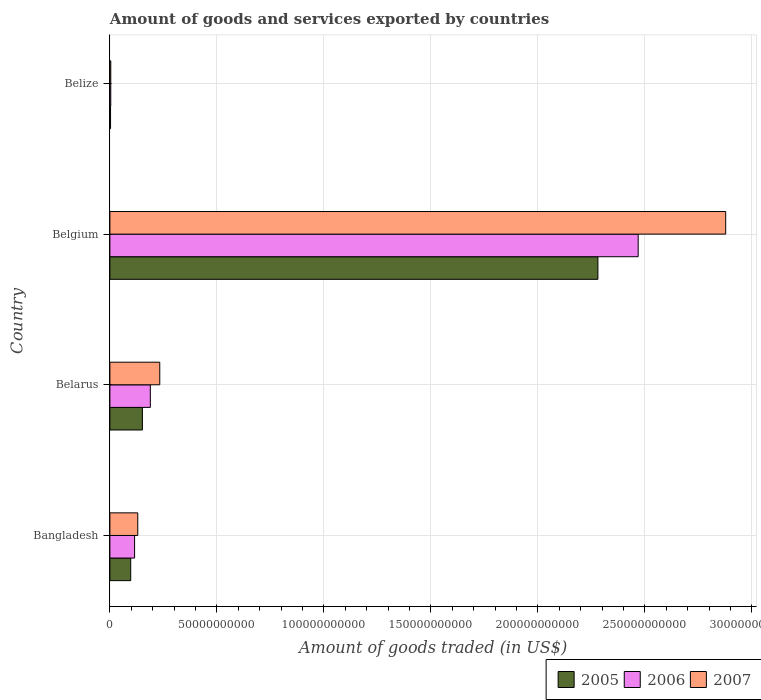How many different coloured bars are there?
Ensure brevity in your answer.  3. How many groups of bars are there?
Offer a terse response. 4. Are the number of bars per tick equal to the number of legend labels?
Your response must be concise. Yes. Are the number of bars on each tick of the Y-axis equal?
Offer a terse response. Yes. In how many cases, is the number of bars for a given country not equal to the number of legend labels?
Ensure brevity in your answer.  0. What is the total amount of goods and services exported in 2005 in Bangladesh?
Give a very brief answer. 9.73e+09. Across all countries, what is the maximum total amount of goods and services exported in 2006?
Provide a short and direct response. 2.47e+11. Across all countries, what is the minimum total amount of goods and services exported in 2007?
Keep it short and to the point. 4.16e+08. In which country was the total amount of goods and services exported in 2007 minimum?
Your answer should be compact. Belize. What is the total total amount of goods and services exported in 2005 in the graph?
Provide a short and direct response. 2.53e+11. What is the difference between the total amount of goods and services exported in 2007 in Bangladesh and that in Belize?
Your answer should be compact. 1.26e+1. What is the difference between the total amount of goods and services exported in 2007 in Bangladesh and the total amount of goods and services exported in 2006 in Belarus?
Offer a very short reply. -5.87e+09. What is the average total amount of goods and services exported in 2006 per country?
Provide a succinct answer. 6.94e+1. What is the difference between the total amount of goods and services exported in 2006 and total amount of goods and services exported in 2007 in Belize?
Ensure brevity in your answer.  -7.34e+06. What is the ratio of the total amount of goods and services exported in 2007 in Belarus to that in Belize?
Make the answer very short. 56. Is the difference between the total amount of goods and services exported in 2006 in Bangladesh and Belize greater than the difference between the total amount of goods and services exported in 2007 in Bangladesh and Belize?
Give a very brief answer. No. What is the difference between the highest and the second highest total amount of goods and services exported in 2007?
Your answer should be very brief. 2.64e+11. What is the difference between the highest and the lowest total amount of goods and services exported in 2007?
Make the answer very short. 2.87e+11. In how many countries, is the total amount of goods and services exported in 2005 greater than the average total amount of goods and services exported in 2005 taken over all countries?
Offer a terse response. 1. Is the sum of the total amount of goods and services exported in 2006 in Belarus and Belize greater than the maximum total amount of goods and services exported in 2007 across all countries?
Keep it short and to the point. No. Is it the case that in every country, the sum of the total amount of goods and services exported in 2006 and total amount of goods and services exported in 2007 is greater than the total amount of goods and services exported in 2005?
Ensure brevity in your answer.  Yes. How many bars are there?
Your answer should be very brief. 12. How many countries are there in the graph?
Your answer should be compact. 4. Are the values on the major ticks of X-axis written in scientific E-notation?
Provide a short and direct response. No. Does the graph contain any zero values?
Your answer should be compact. No. What is the title of the graph?
Provide a short and direct response. Amount of goods and services exported by countries. Does "1998" appear as one of the legend labels in the graph?
Give a very brief answer. No. What is the label or title of the X-axis?
Your answer should be compact. Amount of goods traded (in US$). What is the label or title of the Y-axis?
Ensure brevity in your answer.  Country. What is the Amount of goods traded (in US$) of 2005 in Bangladesh?
Make the answer very short. 9.73e+09. What is the Amount of goods traded (in US$) of 2006 in Bangladesh?
Offer a terse response. 1.15e+1. What is the Amount of goods traded (in US$) in 2007 in Bangladesh?
Give a very brief answer. 1.30e+1. What is the Amount of goods traded (in US$) in 2005 in Belarus?
Provide a short and direct response. 1.52e+1. What is the Amount of goods traded (in US$) of 2006 in Belarus?
Your answer should be very brief. 1.89e+1. What is the Amount of goods traded (in US$) in 2007 in Belarus?
Your response must be concise. 2.33e+1. What is the Amount of goods traded (in US$) of 2005 in Belgium?
Keep it short and to the point. 2.28e+11. What is the Amount of goods traded (in US$) of 2006 in Belgium?
Offer a very short reply. 2.47e+11. What is the Amount of goods traded (in US$) in 2007 in Belgium?
Make the answer very short. 2.88e+11. What is the Amount of goods traded (in US$) of 2005 in Belize?
Your answer should be very brief. 3.08e+08. What is the Amount of goods traded (in US$) of 2006 in Belize?
Your answer should be very brief. 4.09e+08. What is the Amount of goods traded (in US$) of 2007 in Belize?
Offer a very short reply. 4.16e+08. Across all countries, what is the maximum Amount of goods traded (in US$) in 2005?
Offer a very short reply. 2.28e+11. Across all countries, what is the maximum Amount of goods traded (in US$) of 2006?
Offer a very short reply. 2.47e+11. Across all countries, what is the maximum Amount of goods traded (in US$) of 2007?
Offer a terse response. 2.88e+11. Across all countries, what is the minimum Amount of goods traded (in US$) of 2005?
Your answer should be very brief. 3.08e+08. Across all countries, what is the minimum Amount of goods traded (in US$) in 2006?
Keep it short and to the point. 4.09e+08. Across all countries, what is the minimum Amount of goods traded (in US$) of 2007?
Provide a succinct answer. 4.16e+08. What is the total Amount of goods traded (in US$) in 2005 in the graph?
Offer a very short reply. 2.53e+11. What is the total Amount of goods traded (in US$) of 2006 in the graph?
Provide a succinct answer. 2.78e+11. What is the total Amount of goods traded (in US$) of 2007 in the graph?
Your response must be concise. 3.25e+11. What is the difference between the Amount of goods traded (in US$) in 2005 in Bangladesh and that in Belarus?
Give a very brief answer. -5.46e+09. What is the difference between the Amount of goods traded (in US$) in 2006 in Bangladesh and that in Belarus?
Make the answer very short. -7.35e+09. What is the difference between the Amount of goods traded (in US$) of 2007 in Bangladesh and that in Belarus?
Offer a very short reply. -1.03e+1. What is the difference between the Amount of goods traded (in US$) in 2005 in Bangladesh and that in Belgium?
Offer a terse response. -2.18e+11. What is the difference between the Amount of goods traded (in US$) of 2006 in Bangladesh and that in Belgium?
Offer a terse response. -2.35e+11. What is the difference between the Amount of goods traded (in US$) of 2007 in Bangladesh and that in Belgium?
Keep it short and to the point. -2.75e+11. What is the difference between the Amount of goods traded (in US$) of 2005 in Bangladesh and that in Belize?
Your answer should be very brief. 9.42e+09. What is the difference between the Amount of goods traded (in US$) in 2006 in Bangladesh and that in Belize?
Make the answer very short. 1.11e+1. What is the difference between the Amount of goods traded (in US$) in 2007 in Bangladesh and that in Belize?
Your answer should be very brief. 1.26e+1. What is the difference between the Amount of goods traded (in US$) of 2005 in Belarus and that in Belgium?
Your answer should be very brief. -2.13e+11. What is the difference between the Amount of goods traded (in US$) of 2006 in Belarus and that in Belgium?
Ensure brevity in your answer.  -2.28e+11. What is the difference between the Amount of goods traded (in US$) in 2007 in Belarus and that in Belgium?
Offer a terse response. -2.64e+11. What is the difference between the Amount of goods traded (in US$) of 2005 in Belarus and that in Belize?
Offer a very short reply. 1.49e+1. What is the difference between the Amount of goods traded (in US$) in 2006 in Belarus and that in Belize?
Your response must be concise. 1.85e+1. What is the difference between the Amount of goods traded (in US$) of 2007 in Belarus and that in Belize?
Provide a short and direct response. 2.29e+1. What is the difference between the Amount of goods traded (in US$) of 2005 in Belgium and that in Belize?
Give a very brief answer. 2.28e+11. What is the difference between the Amount of goods traded (in US$) in 2006 in Belgium and that in Belize?
Offer a very short reply. 2.46e+11. What is the difference between the Amount of goods traded (in US$) of 2007 in Belgium and that in Belize?
Give a very brief answer. 2.87e+11. What is the difference between the Amount of goods traded (in US$) in 2005 in Bangladesh and the Amount of goods traded (in US$) in 2006 in Belarus?
Provide a short and direct response. -9.16e+09. What is the difference between the Amount of goods traded (in US$) in 2005 in Bangladesh and the Amount of goods traded (in US$) in 2007 in Belarus?
Your answer should be compact. -1.36e+1. What is the difference between the Amount of goods traded (in US$) of 2006 in Bangladesh and the Amount of goods traded (in US$) of 2007 in Belarus?
Ensure brevity in your answer.  -1.18e+1. What is the difference between the Amount of goods traded (in US$) in 2005 in Bangladesh and the Amount of goods traded (in US$) in 2006 in Belgium?
Offer a very short reply. -2.37e+11. What is the difference between the Amount of goods traded (in US$) in 2005 in Bangladesh and the Amount of goods traded (in US$) in 2007 in Belgium?
Your answer should be very brief. -2.78e+11. What is the difference between the Amount of goods traded (in US$) in 2006 in Bangladesh and the Amount of goods traded (in US$) in 2007 in Belgium?
Keep it short and to the point. -2.76e+11. What is the difference between the Amount of goods traded (in US$) in 2005 in Bangladesh and the Amount of goods traded (in US$) in 2006 in Belize?
Offer a terse response. 9.32e+09. What is the difference between the Amount of goods traded (in US$) in 2005 in Bangladesh and the Amount of goods traded (in US$) in 2007 in Belize?
Keep it short and to the point. 9.32e+09. What is the difference between the Amount of goods traded (in US$) of 2006 in Bangladesh and the Amount of goods traded (in US$) of 2007 in Belize?
Keep it short and to the point. 1.11e+1. What is the difference between the Amount of goods traded (in US$) in 2005 in Belarus and the Amount of goods traded (in US$) in 2006 in Belgium?
Provide a short and direct response. -2.32e+11. What is the difference between the Amount of goods traded (in US$) of 2005 in Belarus and the Amount of goods traded (in US$) of 2007 in Belgium?
Your response must be concise. -2.73e+11. What is the difference between the Amount of goods traded (in US$) in 2006 in Belarus and the Amount of goods traded (in US$) in 2007 in Belgium?
Offer a terse response. -2.69e+11. What is the difference between the Amount of goods traded (in US$) in 2005 in Belarus and the Amount of goods traded (in US$) in 2006 in Belize?
Your answer should be compact. 1.48e+1. What is the difference between the Amount of goods traded (in US$) of 2005 in Belarus and the Amount of goods traded (in US$) of 2007 in Belize?
Give a very brief answer. 1.48e+1. What is the difference between the Amount of goods traded (in US$) in 2006 in Belarus and the Amount of goods traded (in US$) in 2007 in Belize?
Your response must be concise. 1.85e+1. What is the difference between the Amount of goods traded (in US$) in 2005 in Belgium and the Amount of goods traded (in US$) in 2006 in Belize?
Keep it short and to the point. 2.28e+11. What is the difference between the Amount of goods traded (in US$) in 2005 in Belgium and the Amount of goods traded (in US$) in 2007 in Belize?
Provide a short and direct response. 2.28e+11. What is the difference between the Amount of goods traded (in US$) of 2006 in Belgium and the Amount of goods traded (in US$) of 2007 in Belize?
Keep it short and to the point. 2.46e+11. What is the average Amount of goods traded (in US$) in 2005 per country?
Offer a terse response. 6.33e+1. What is the average Amount of goods traded (in US$) of 2006 per country?
Offer a very short reply. 6.94e+1. What is the average Amount of goods traded (in US$) of 2007 per country?
Keep it short and to the point. 8.11e+1. What is the difference between the Amount of goods traded (in US$) in 2005 and Amount of goods traded (in US$) in 2006 in Bangladesh?
Give a very brief answer. -1.81e+09. What is the difference between the Amount of goods traded (in US$) of 2005 and Amount of goods traded (in US$) of 2007 in Bangladesh?
Make the answer very short. -3.30e+09. What is the difference between the Amount of goods traded (in US$) in 2006 and Amount of goods traded (in US$) in 2007 in Bangladesh?
Provide a succinct answer. -1.48e+09. What is the difference between the Amount of goods traded (in US$) in 2005 and Amount of goods traded (in US$) in 2006 in Belarus?
Ensure brevity in your answer.  -3.70e+09. What is the difference between the Amount of goods traded (in US$) in 2005 and Amount of goods traded (in US$) in 2007 in Belarus?
Your answer should be very brief. -8.12e+09. What is the difference between the Amount of goods traded (in US$) in 2006 and Amount of goods traded (in US$) in 2007 in Belarus?
Offer a terse response. -4.41e+09. What is the difference between the Amount of goods traded (in US$) of 2005 and Amount of goods traded (in US$) of 2006 in Belgium?
Provide a short and direct response. -1.88e+1. What is the difference between the Amount of goods traded (in US$) in 2005 and Amount of goods traded (in US$) in 2007 in Belgium?
Offer a very short reply. -5.97e+1. What is the difference between the Amount of goods traded (in US$) in 2006 and Amount of goods traded (in US$) in 2007 in Belgium?
Provide a short and direct response. -4.09e+1. What is the difference between the Amount of goods traded (in US$) of 2005 and Amount of goods traded (in US$) of 2006 in Belize?
Offer a very short reply. -1.01e+08. What is the difference between the Amount of goods traded (in US$) of 2005 and Amount of goods traded (in US$) of 2007 in Belize?
Make the answer very short. -1.08e+08. What is the difference between the Amount of goods traded (in US$) of 2006 and Amount of goods traded (in US$) of 2007 in Belize?
Keep it short and to the point. -7.34e+06. What is the ratio of the Amount of goods traded (in US$) in 2005 in Bangladesh to that in Belarus?
Keep it short and to the point. 0.64. What is the ratio of the Amount of goods traded (in US$) in 2006 in Bangladesh to that in Belarus?
Provide a succinct answer. 0.61. What is the ratio of the Amount of goods traded (in US$) of 2007 in Bangladesh to that in Belarus?
Keep it short and to the point. 0.56. What is the ratio of the Amount of goods traded (in US$) of 2005 in Bangladesh to that in Belgium?
Make the answer very short. 0.04. What is the ratio of the Amount of goods traded (in US$) of 2006 in Bangladesh to that in Belgium?
Ensure brevity in your answer.  0.05. What is the ratio of the Amount of goods traded (in US$) of 2007 in Bangladesh to that in Belgium?
Ensure brevity in your answer.  0.05. What is the ratio of the Amount of goods traded (in US$) in 2005 in Bangladesh to that in Belize?
Your answer should be very brief. 31.59. What is the ratio of the Amount of goods traded (in US$) in 2006 in Bangladesh to that in Belize?
Your answer should be compact. 28.23. What is the ratio of the Amount of goods traded (in US$) in 2007 in Bangladesh to that in Belize?
Offer a very short reply. 31.3. What is the ratio of the Amount of goods traded (in US$) in 2005 in Belarus to that in Belgium?
Your answer should be compact. 0.07. What is the ratio of the Amount of goods traded (in US$) of 2006 in Belarus to that in Belgium?
Provide a succinct answer. 0.08. What is the ratio of the Amount of goods traded (in US$) in 2007 in Belarus to that in Belgium?
Provide a short and direct response. 0.08. What is the ratio of the Amount of goods traded (in US$) of 2005 in Belarus to that in Belize?
Ensure brevity in your answer.  49.32. What is the ratio of the Amount of goods traded (in US$) of 2006 in Belarus to that in Belize?
Provide a short and direct response. 46.21. What is the ratio of the Amount of goods traded (in US$) of 2007 in Belarus to that in Belize?
Ensure brevity in your answer.  56. What is the ratio of the Amount of goods traded (in US$) of 2005 in Belgium to that in Belize?
Give a very brief answer. 740.3. What is the ratio of the Amount of goods traded (in US$) of 2006 in Belgium to that in Belize?
Give a very brief answer. 603.72. What is the ratio of the Amount of goods traded (in US$) of 2007 in Belgium to that in Belize?
Provide a short and direct response. 691.32. What is the difference between the highest and the second highest Amount of goods traded (in US$) of 2005?
Your response must be concise. 2.13e+11. What is the difference between the highest and the second highest Amount of goods traded (in US$) in 2006?
Your answer should be very brief. 2.28e+11. What is the difference between the highest and the second highest Amount of goods traded (in US$) in 2007?
Provide a short and direct response. 2.64e+11. What is the difference between the highest and the lowest Amount of goods traded (in US$) of 2005?
Provide a short and direct response. 2.28e+11. What is the difference between the highest and the lowest Amount of goods traded (in US$) of 2006?
Offer a terse response. 2.46e+11. What is the difference between the highest and the lowest Amount of goods traded (in US$) in 2007?
Make the answer very short. 2.87e+11. 